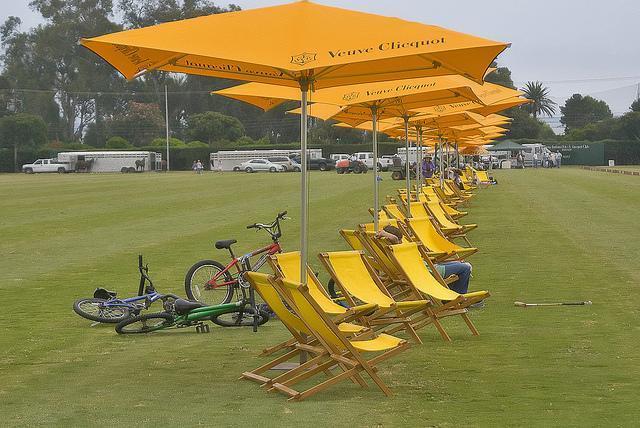How many bicycles are by the chairs?
Give a very brief answer. 3. How many umbrellas are there?
Give a very brief answer. 4. How many bicycles can you see?
Give a very brief answer. 3. How many chairs can be seen?
Give a very brief answer. 6. 